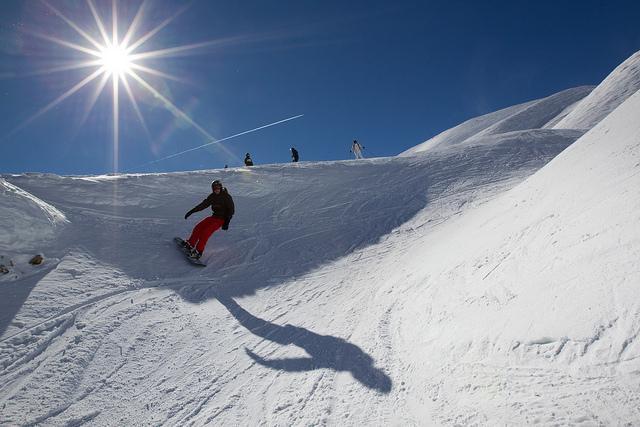How many snowboarders are in the picture?
Give a very brief answer. 1. How many orange cups are on the table?
Give a very brief answer. 0. 